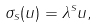<formula> <loc_0><loc_0><loc_500><loc_500>\sigma _ { s } ( u ) = \lambda ^ { s } u ,</formula> 